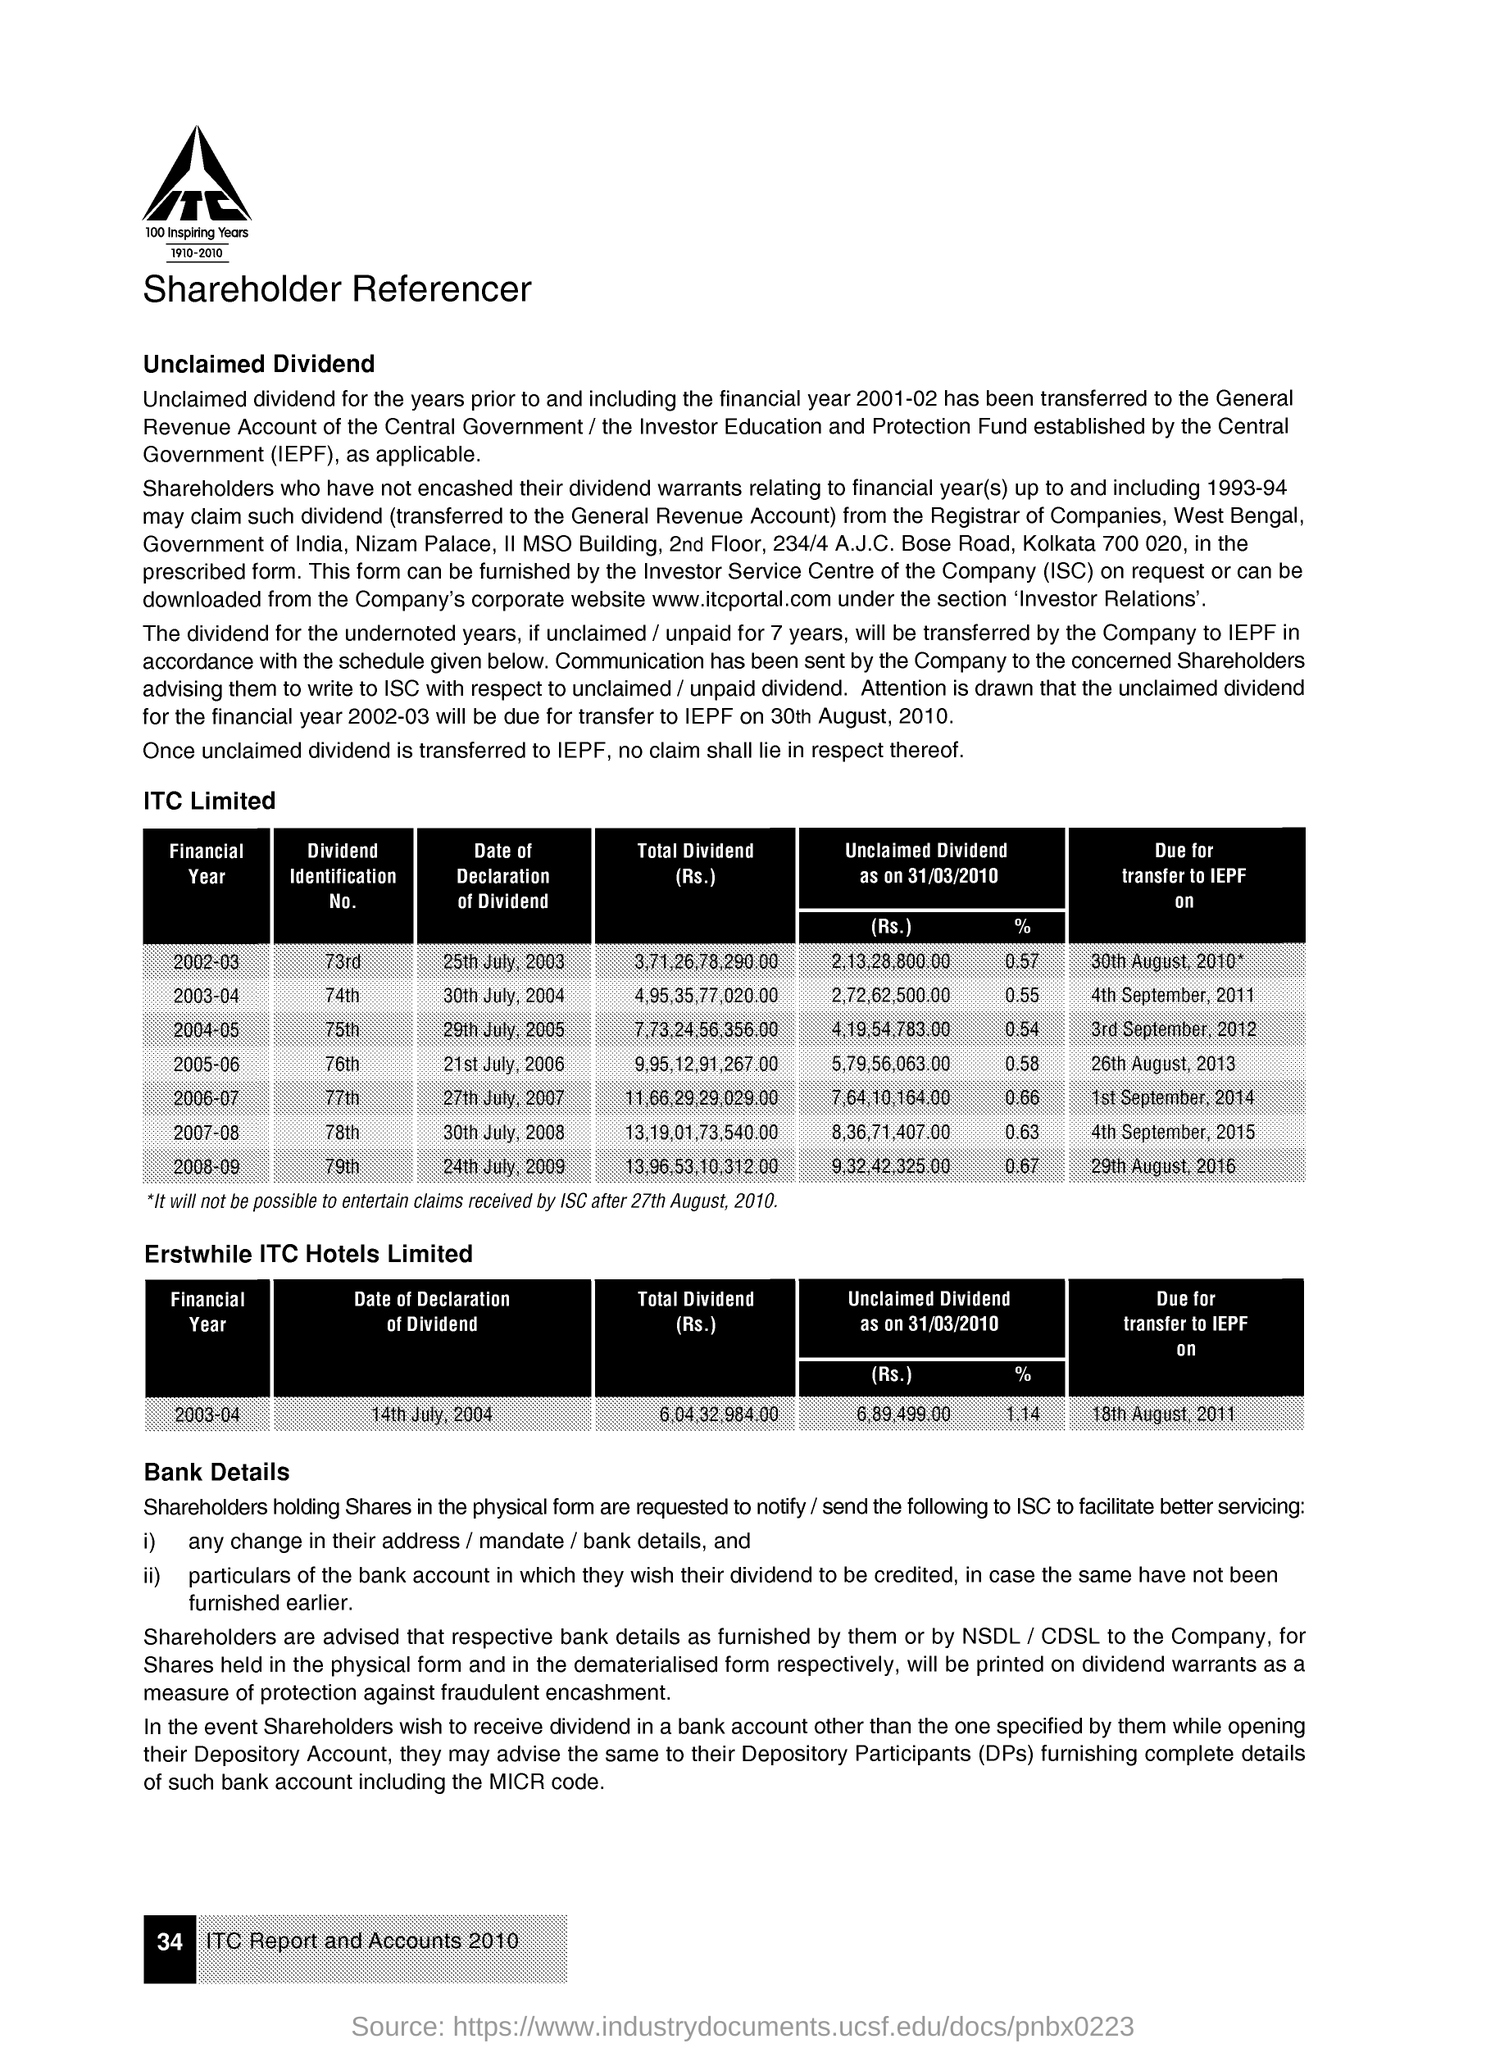What is the Dividend Identification No. for Financial Year 2002-03?
Ensure brevity in your answer.  73rd. What is the Dividend Identification No. for Financial Year 2003-04?
Your answer should be compact. 74th. What is the Dividend Identification No. for Financial Year 2004-05?
Your answer should be very brief. 75th. What is the Dividend Identification No. for Financial Year 2005-06?
Provide a short and direct response. 76th. What is the Dividend Identification No. for Financial Year 2006-07?
Ensure brevity in your answer.  77th. What is the Dividend Identification No. for Financial Year 2007-08?
Make the answer very short. 78th. What is the Dividend Identification No. for Financial Year 2008-09?
Ensure brevity in your answer.  79th. 